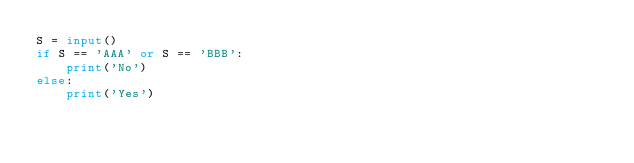Convert code to text. <code><loc_0><loc_0><loc_500><loc_500><_Python_>S = input()
if S == 'AAA' or S == 'BBB':
    print('No')
else:
    print('Yes')</code> 